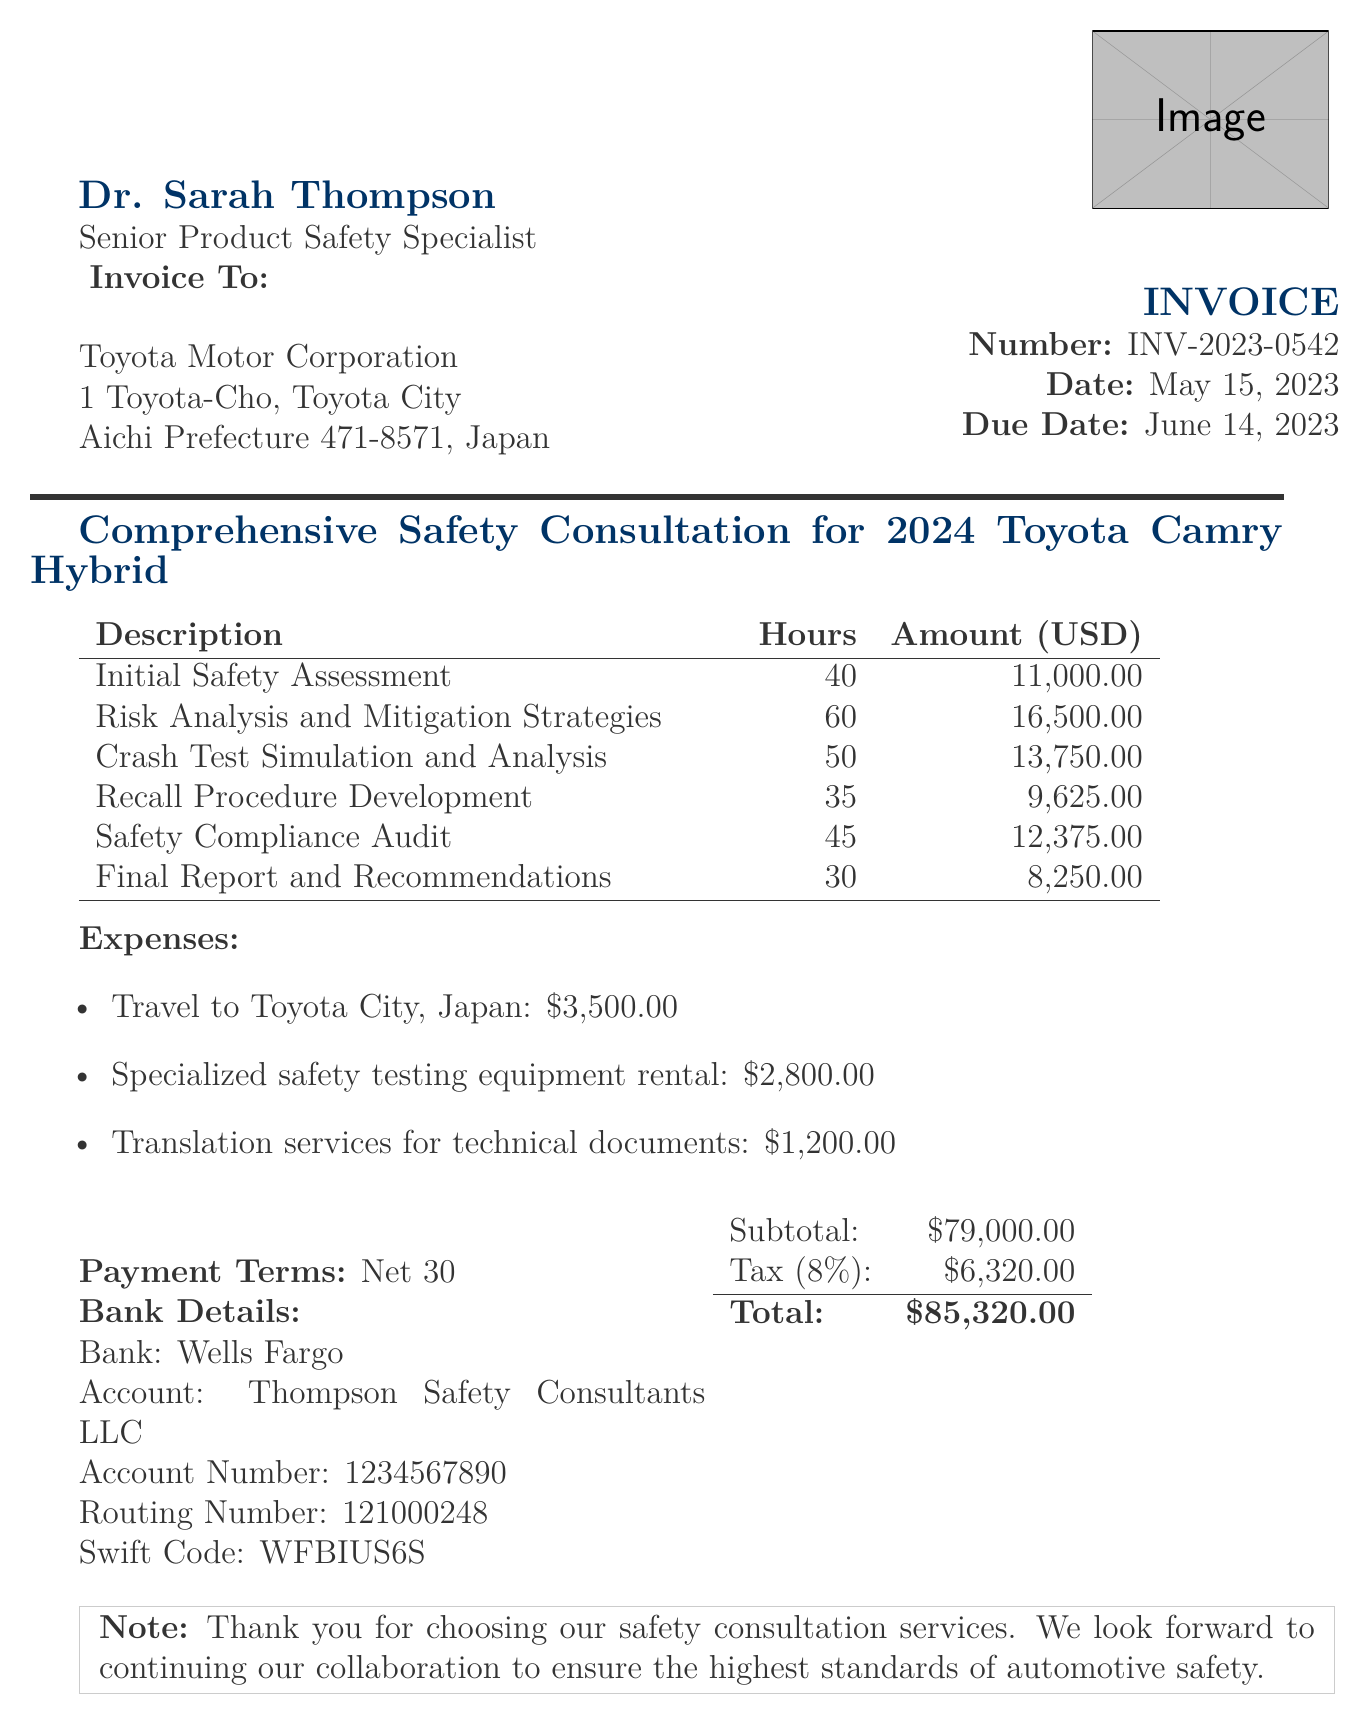What is the invoice number? The invoice number is a specific identifier for this document, presented clearly at the beginning.
Answer: INV-2023-0542 Who is the consultant? The name of the consultant is provided at the top of the document, identifying the individual responsible for the services.
Answer: Dr. Sarah Thompson What is the total amount due? The total amount is calculated as the sum of all services, expenses, and tax applied, detailed at the end.
Answer: $85,320.00 How many hours were dedicated to the Recall Procedure Development? The document specifies the hours required for each project milestone, including this one.
Answer: 35 What is the due date for payment? The due date is clearly stated in the document to inform the client regarding payment timelines.
Answer: June 14, 2023 How many milestones are listed in the invoice? The number of milestones is indicated by the specific entries in the milestones table, which can be counted.
Answer: 6 What is the tax rate applied to the invoice? The tax rate is explicitly mentioned in the document, indicating how it is calculated on the subtotal.
Answer: 8% What are the payment terms specified? The payment terms provide information on the timeline for payment expected from the client.
Answer: Net 30 What is the description of the final project milestone? The description relates to the comprehensive tasks completed in the last milestone and is provided in detail.
Answer: Comprehensive report detailing findings and safety enhancement recommendations 